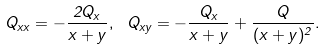<formula> <loc_0><loc_0><loc_500><loc_500>Q _ { x x } = - \frac { 2 Q _ { x } } { x + y } , \ Q _ { x y } = - \frac { Q _ { x } } { x + y } + \frac { Q } { ( x + y ) ^ { 2 } } .</formula> 